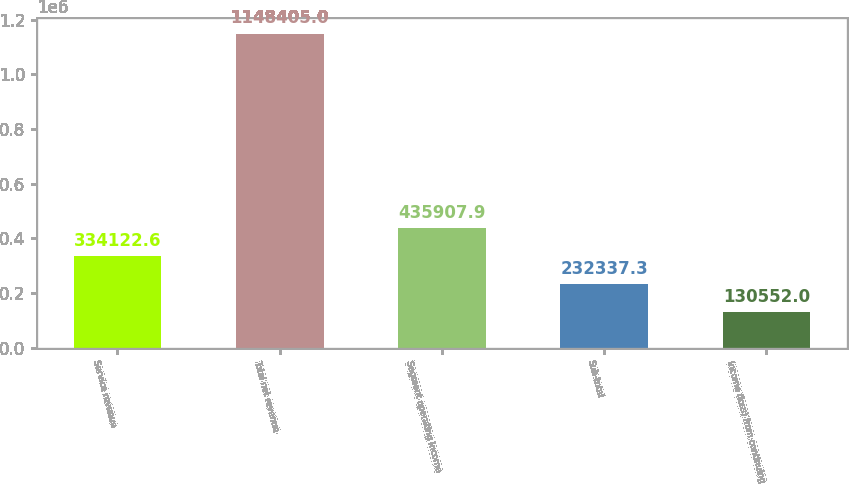Convert chart to OTSL. <chart><loc_0><loc_0><loc_500><loc_500><bar_chart><fcel>Service revenue<fcel>Total net revenue<fcel>Segment operating income<fcel>Sub-total<fcel>Income (loss) from continuing<nl><fcel>334123<fcel>1.1484e+06<fcel>435908<fcel>232337<fcel>130552<nl></chart> 